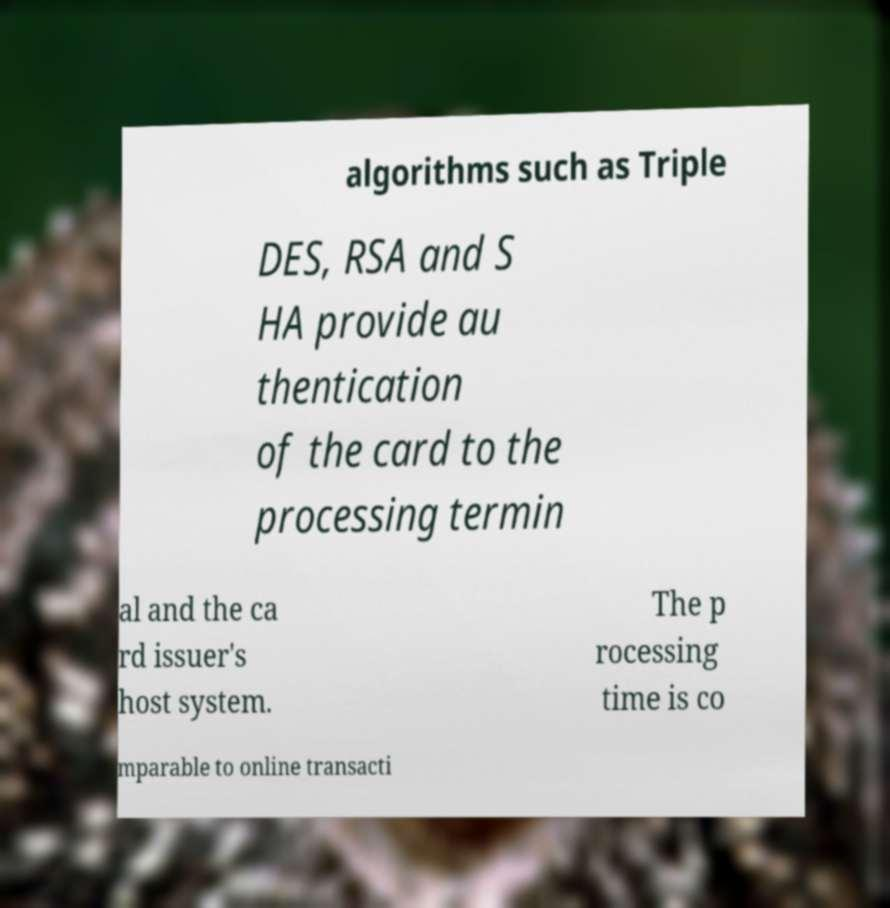Could you extract and type out the text from this image? algorithms such as Triple DES, RSA and S HA provide au thentication of the card to the processing termin al and the ca rd issuer's host system. The p rocessing time is co mparable to online transacti 